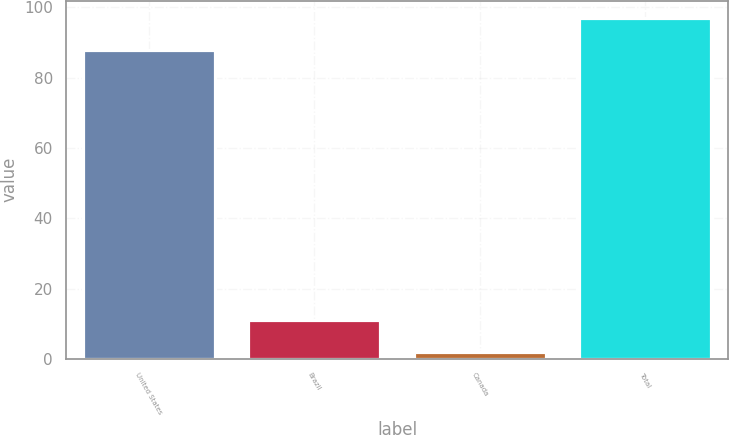Convert chart to OTSL. <chart><loc_0><loc_0><loc_500><loc_500><bar_chart><fcel>United States<fcel>Brazil<fcel>Canada<fcel>Total<nl><fcel>88<fcel>11.1<fcel>2<fcel>97.1<nl></chart> 